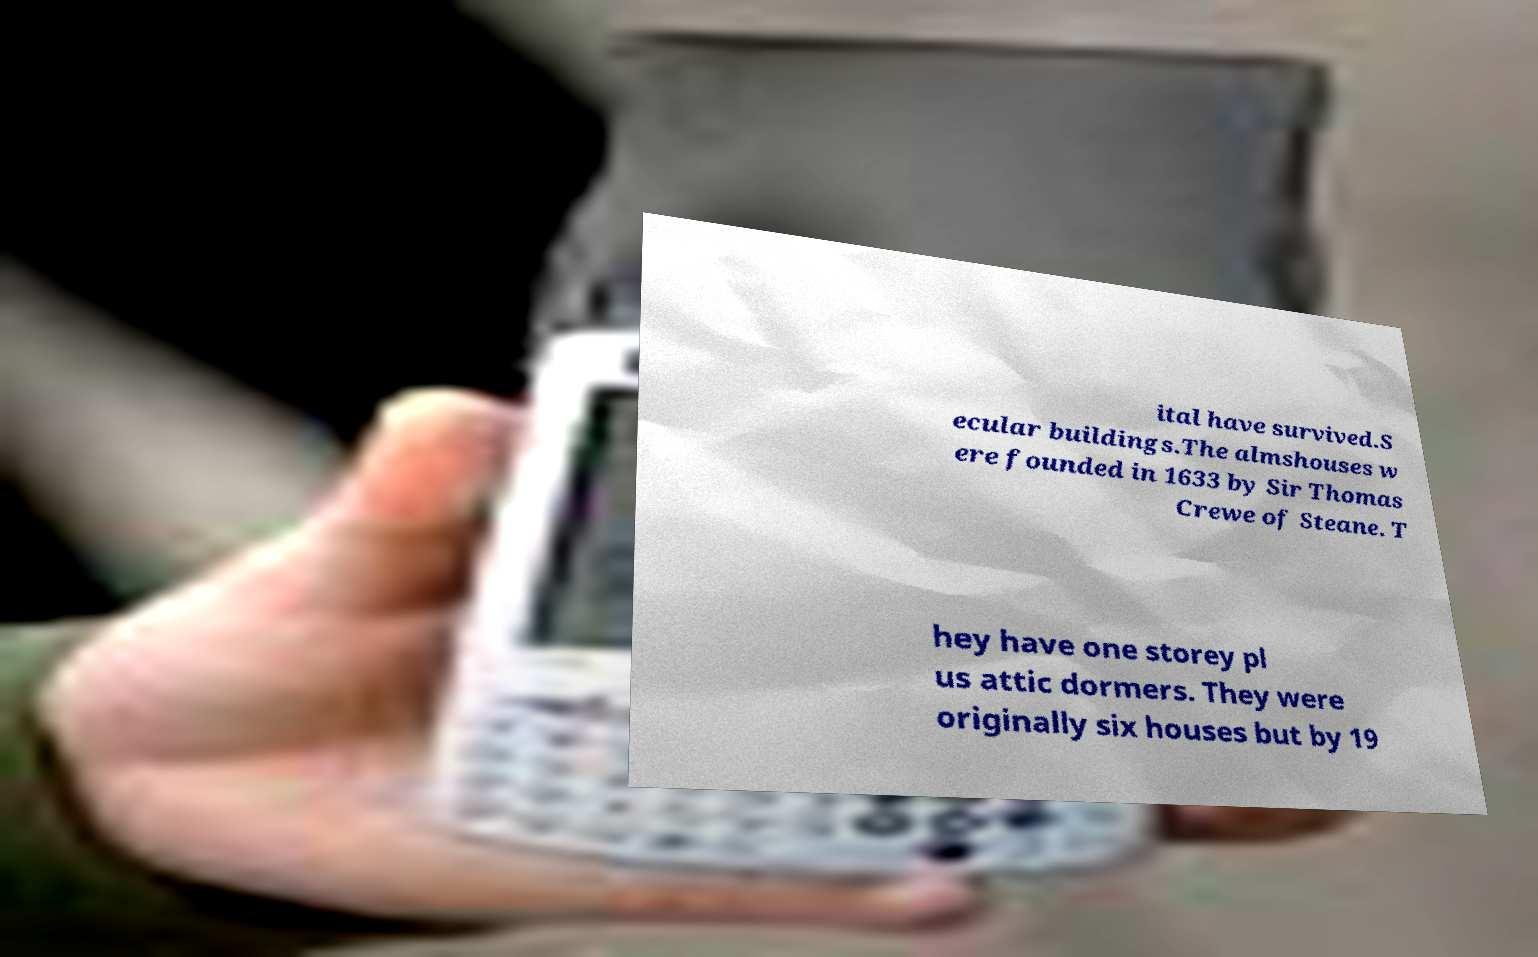Could you assist in decoding the text presented in this image and type it out clearly? ital have survived.S ecular buildings.The almshouses w ere founded in 1633 by Sir Thomas Crewe of Steane. T hey have one storey pl us attic dormers. They were originally six houses but by 19 